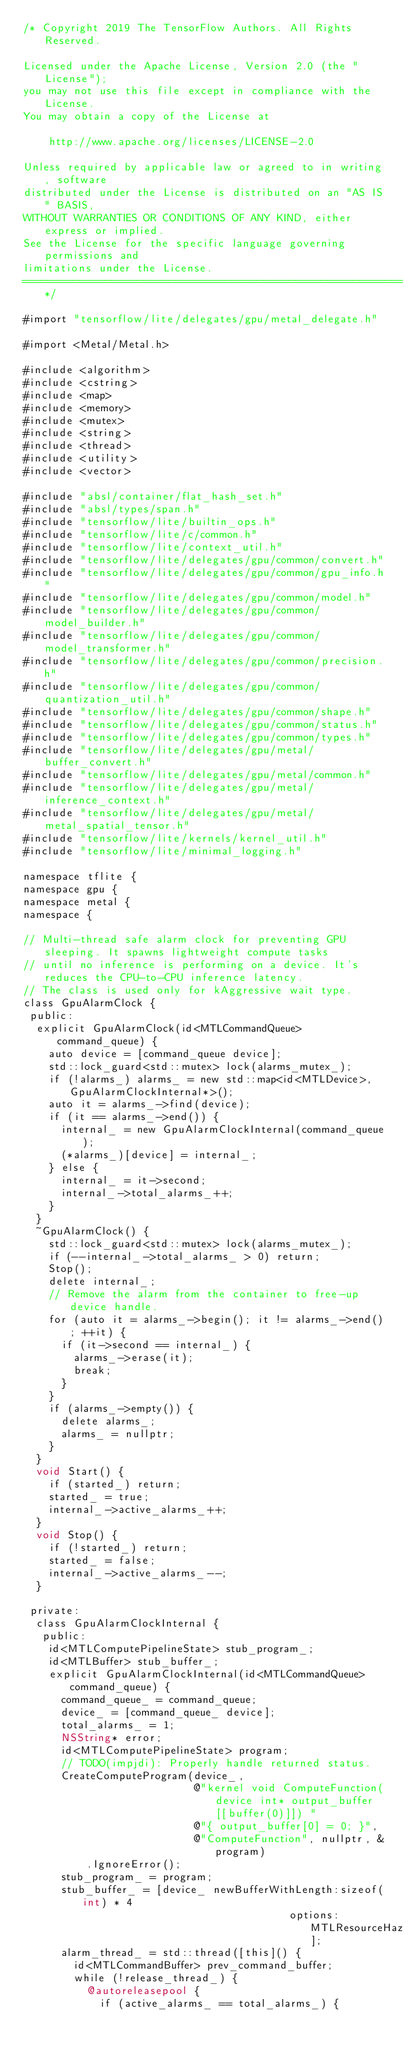<code> <loc_0><loc_0><loc_500><loc_500><_ObjectiveC_>/* Copyright 2019 The TensorFlow Authors. All Rights Reserved.

Licensed under the Apache License, Version 2.0 (the "License");
you may not use this file except in compliance with the License.
You may obtain a copy of the License at

    http://www.apache.org/licenses/LICENSE-2.0

Unless required by applicable law or agreed to in writing, software
distributed under the License is distributed on an "AS IS" BASIS,
WITHOUT WARRANTIES OR CONDITIONS OF ANY KIND, either express or implied.
See the License for the specific language governing permissions and
limitations under the License.
==============================================================================*/

#import "tensorflow/lite/delegates/gpu/metal_delegate.h"

#import <Metal/Metal.h>

#include <algorithm>
#include <cstring>
#include <map>
#include <memory>
#include <mutex>
#include <string>
#include <thread>
#include <utility>
#include <vector>

#include "absl/container/flat_hash_set.h"
#include "absl/types/span.h"
#include "tensorflow/lite/builtin_ops.h"
#include "tensorflow/lite/c/common.h"
#include "tensorflow/lite/context_util.h"
#include "tensorflow/lite/delegates/gpu/common/convert.h"
#include "tensorflow/lite/delegates/gpu/common/gpu_info.h"
#include "tensorflow/lite/delegates/gpu/common/model.h"
#include "tensorflow/lite/delegates/gpu/common/model_builder.h"
#include "tensorflow/lite/delegates/gpu/common/model_transformer.h"
#include "tensorflow/lite/delegates/gpu/common/precision.h"
#include "tensorflow/lite/delegates/gpu/common/quantization_util.h"
#include "tensorflow/lite/delegates/gpu/common/shape.h"
#include "tensorflow/lite/delegates/gpu/common/status.h"
#include "tensorflow/lite/delegates/gpu/common/types.h"
#include "tensorflow/lite/delegates/gpu/metal/buffer_convert.h"
#include "tensorflow/lite/delegates/gpu/metal/common.h"
#include "tensorflow/lite/delegates/gpu/metal/inference_context.h"
#include "tensorflow/lite/delegates/gpu/metal/metal_spatial_tensor.h"
#include "tensorflow/lite/kernels/kernel_util.h"
#include "tensorflow/lite/minimal_logging.h"

namespace tflite {
namespace gpu {
namespace metal {
namespace {

// Multi-thread safe alarm clock for preventing GPU sleeping. It spawns lightweight compute tasks
// until no inference is performing on a device. It's reduces the CPU-to-CPU inference latency.
// The class is used only for kAggressive wait type.
class GpuAlarmClock {
 public:
  explicit GpuAlarmClock(id<MTLCommandQueue> command_queue) {
    auto device = [command_queue device];
    std::lock_guard<std::mutex> lock(alarms_mutex_);
    if (!alarms_) alarms_ = new std::map<id<MTLDevice>, GpuAlarmClockInternal*>();
    auto it = alarms_->find(device);
    if (it == alarms_->end()) {
      internal_ = new GpuAlarmClockInternal(command_queue);
      (*alarms_)[device] = internal_;
    } else {
      internal_ = it->second;
      internal_->total_alarms_++;
    }
  }
  ~GpuAlarmClock() {
    std::lock_guard<std::mutex> lock(alarms_mutex_);
    if (--internal_->total_alarms_ > 0) return;
    Stop();
    delete internal_;
    // Remove the alarm from the container to free-up device handle.
    for (auto it = alarms_->begin(); it != alarms_->end(); ++it) {
      if (it->second == internal_) {
        alarms_->erase(it);
        break;
      }
    }
    if (alarms_->empty()) {
      delete alarms_;
      alarms_ = nullptr;
    }
  }
  void Start() {
    if (started_) return;
    started_ = true;
    internal_->active_alarms_++;
  }
  void Stop() {
    if (!started_) return;
    started_ = false;
    internal_->active_alarms_--;
  }

 private:
  class GpuAlarmClockInternal {
   public:
    id<MTLComputePipelineState> stub_program_;
    id<MTLBuffer> stub_buffer_;
    explicit GpuAlarmClockInternal(id<MTLCommandQueue> command_queue) {
      command_queue_ = command_queue;
      device_ = [command_queue_ device];
      total_alarms_ = 1;
      NSString* error;
      id<MTLComputePipelineState> program;
      // TODO(impjdi): Properly handle returned status.
      CreateComputeProgram(device_,
                           @"kernel void ComputeFunction(device int* output_buffer [[buffer(0)]]) "
                           @"{ output_buffer[0] = 0; }",
                           @"ComputeFunction", nullptr, &program)
          .IgnoreError();
      stub_program_ = program;
      stub_buffer_ = [device_ newBufferWithLength:sizeof(int) * 4
                                          options:MTLResourceHazardTrackingModeUntracked];
      alarm_thread_ = std::thread([this]() {
        id<MTLCommandBuffer> prev_command_buffer;
        while (!release_thread_) {
          @autoreleasepool {
            if (active_alarms_ == total_alarms_) {</code> 